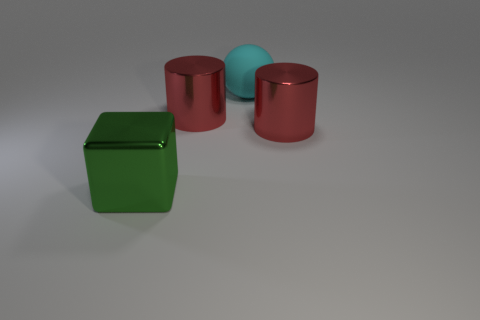Add 1 cyan matte balls. How many objects exist? 5 Subtract all blocks. How many objects are left? 3 Subtract all big red things. Subtract all big red metal objects. How many objects are left? 0 Add 3 cyan rubber balls. How many cyan rubber balls are left? 4 Add 3 small red matte things. How many small red matte things exist? 3 Subtract 0 yellow cylinders. How many objects are left? 4 Subtract all cyan blocks. Subtract all green balls. How many blocks are left? 1 